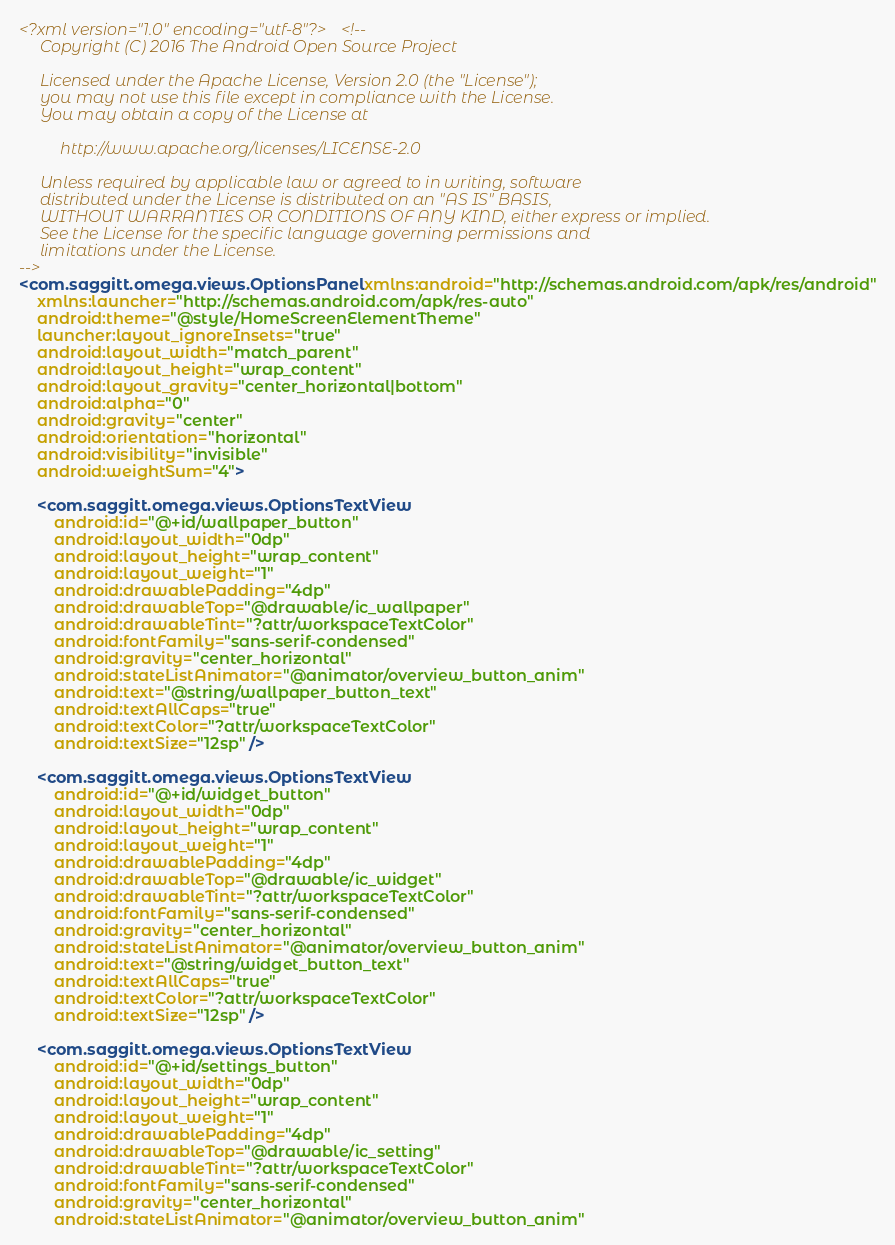<code> <loc_0><loc_0><loc_500><loc_500><_XML_><?xml version="1.0" encoding="utf-8"?><!--
     Copyright (C) 2016 The Android Open Source Project

     Licensed under the Apache License, Version 2.0 (the "License");
     you may not use this file except in compliance with the License.
     You may obtain a copy of the License at

          http://www.apache.org/licenses/LICENSE-2.0

     Unless required by applicable law or agreed to in writing, software
     distributed under the License is distributed on an "AS IS" BASIS,
     WITHOUT WARRANTIES OR CONDITIONS OF ANY KIND, either express or implied.
     See the License for the specific language governing permissions and
     limitations under the License.
-->
<com.saggitt.omega.views.OptionsPanel xmlns:android="http://schemas.android.com/apk/res/android"
    xmlns:launcher="http://schemas.android.com/apk/res-auto"
    android:theme="@style/HomeScreenElementTheme"
    launcher:layout_ignoreInsets="true"
    android:layout_width="match_parent"
    android:layout_height="wrap_content"
    android:layout_gravity="center_horizontal|bottom"
    android:alpha="0"
    android:gravity="center"
    android:orientation="horizontal"
    android:visibility="invisible"
    android:weightSum="4">

    <com.saggitt.omega.views.OptionsTextView
        android:id="@+id/wallpaper_button"
        android:layout_width="0dp"
        android:layout_height="wrap_content"
        android:layout_weight="1"
        android:drawablePadding="4dp"
        android:drawableTop="@drawable/ic_wallpaper"
        android:drawableTint="?attr/workspaceTextColor"
        android:fontFamily="sans-serif-condensed"
        android:gravity="center_horizontal"
        android:stateListAnimator="@animator/overview_button_anim"
        android:text="@string/wallpaper_button_text"
        android:textAllCaps="true"
        android:textColor="?attr/workspaceTextColor"
        android:textSize="12sp" />

    <com.saggitt.omega.views.OptionsTextView
        android:id="@+id/widget_button"
        android:layout_width="0dp"
        android:layout_height="wrap_content"
        android:layout_weight="1"
        android:drawablePadding="4dp"
        android:drawableTop="@drawable/ic_widget"
        android:drawableTint="?attr/workspaceTextColor"
        android:fontFamily="sans-serif-condensed"
        android:gravity="center_horizontal"
        android:stateListAnimator="@animator/overview_button_anim"
        android:text="@string/widget_button_text"
        android:textAllCaps="true"
        android:textColor="?attr/workspaceTextColor"
        android:textSize="12sp" />

    <com.saggitt.omega.views.OptionsTextView
        android:id="@+id/settings_button"
        android:layout_width="0dp"
        android:layout_height="wrap_content"
        android:layout_weight="1"
        android:drawablePadding="4dp"
        android:drawableTop="@drawable/ic_setting"
        android:drawableTint="?attr/workspaceTextColor"
        android:fontFamily="sans-serif-condensed"
        android:gravity="center_horizontal"
        android:stateListAnimator="@animator/overview_button_anim"</code> 